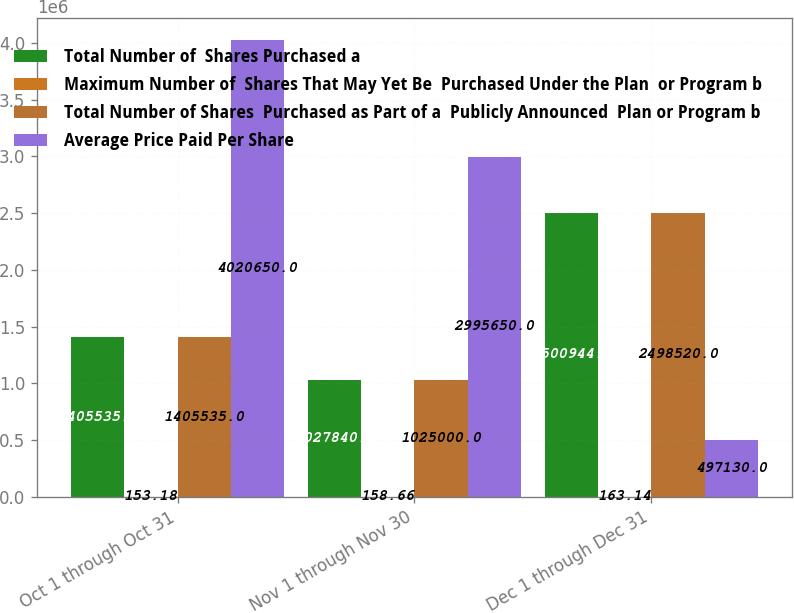Convert chart to OTSL. <chart><loc_0><loc_0><loc_500><loc_500><stacked_bar_chart><ecel><fcel>Oct 1 through Oct 31<fcel>Nov 1 through Nov 30<fcel>Dec 1 through Dec 31<nl><fcel>Total Number of  Shares Purchased a<fcel>1.40554e+06<fcel>1.02784e+06<fcel>2.50094e+06<nl><fcel>Maximum Number of  Shares That May Yet Be  Purchased Under the Plan  or Program b<fcel>153.18<fcel>158.66<fcel>163.14<nl><fcel>Total Number of Shares  Purchased as Part of a  Publicly Announced  Plan or Program b<fcel>1.40554e+06<fcel>1.025e+06<fcel>2.49852e+06<nl><fcel>Average Price Paid Per Share<fcel>4.02065e+06<fcel>2.99565e+06<fcel>497130<nl></chart> 